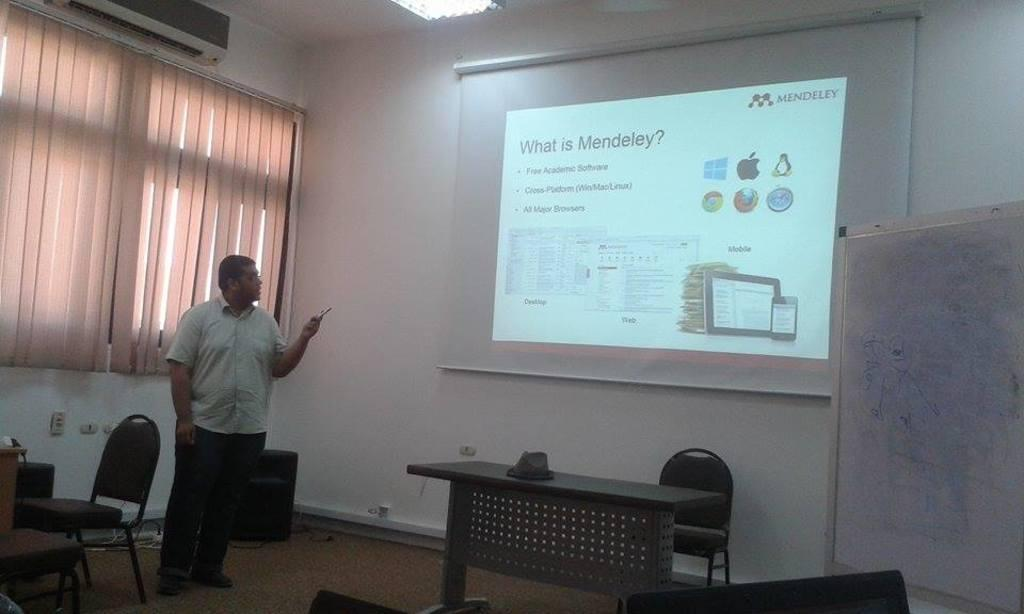What is the main subject of the image? There is a person in the image. What is the person doing in the image? The person is standing. What object is the person holding in the image? The person is holding a remote in his hand. What can be seen on the wall in the image? There is a screen on the wall. What furniture is present in the room in the image? There is a table and a chair in the room. What thought is the person having while holding the remote in the image? There is no indication of the person's thoughts in the image, as we cannot see inside their mind. Is there a minister present in the image? There is no mention of a minister or any religious figure in the image. 